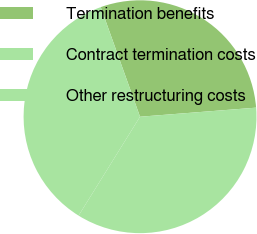<chart> <loc_0><loc_0><loc_500><loc_500><pie_chart><fcel>Termination benefits<fcel>Contract termination costs<fcel>Other restructuring costs<nl><fcel>29.24%<fcel>35.09%<fcel>35.67%<nl></chart> 